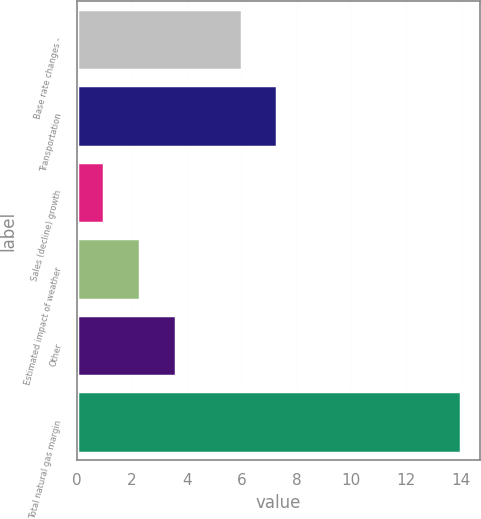Convert chart to OTSL. <chart><loc_0><loc_0><loc_500><loc_500><bar_chart><fcel>Base rate changes -<fcel>Transportation<fcel>Sales (decline) growth<fcel>Estimated impact of weather<fcel>Other<fcel>Total natural gas margin<nl><fcel>6<fcel>7.3<fcel>1<fcel>2.3<fcel>3.6<fcel>14<nl></chart> 